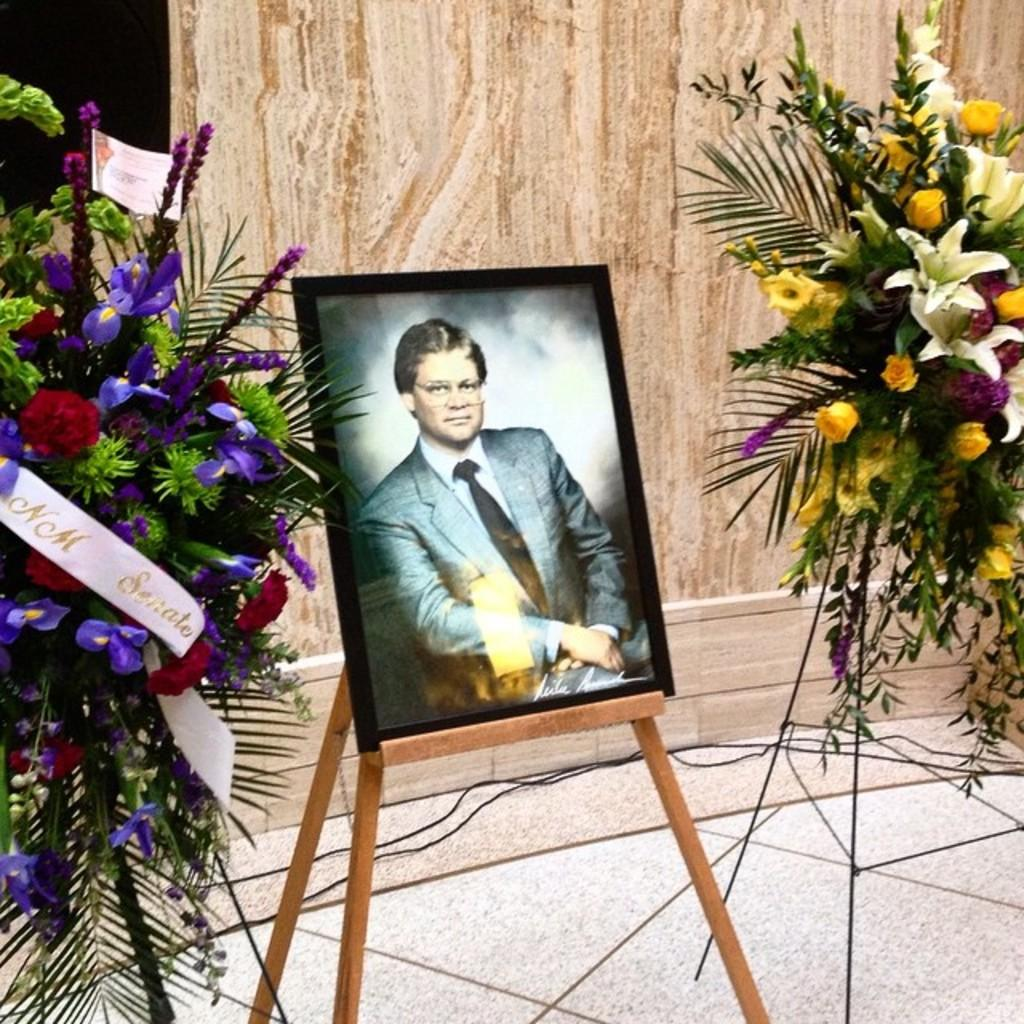What is depicted in the painting in the image? There is a painting of a person in the image. What is used to hold the painting in the image? There is a painting stand in the image. What type of decorative items can be seen on both sides of the image? There are flower bouquets on the right side and the left side of the image. What can be seen in the background of the image? There is a wall in the background of the image. How many rabbits are visible in the image? There are no rabbits present in the image. What type of ear is shown on the person in the painting? The image is a painting, and it does not show the person's ear. 